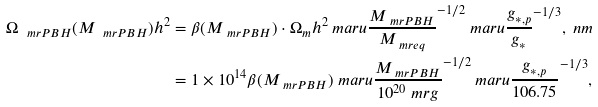Convert formula to latex. <formula><loc_0><loc_0><loc_500><loc_500>\Omega _ { \ m r { P B H } } ( M _ { \ m r { P B H } } ) h ^ { 2 } & = \beta ( M _ { \ m r { P B H } } ) \cdot \Omega _ { m } h ^ { 2 } \ m a r u { \frac { M _ { \ m r { P B H } } } { M _ { \ m r { e q } } } } ^ { - 1 / 2 } \ m a r u { \frac { g _ { \ast , p } } { g _ { \ast } } } ^ { - 1 / 3 } , \ n m \\ & = 1 \times 1 0 ^ { 1 4 } \beta ( M _ { \ m r { P B H } } ) \ m a r u { \frac { M _ { \ m r { P B H } } } { 1 0 ^ { 2 0 } \ m r { g } } } ^ { - 1 / 2 } \ m a r u { \frac { g _ { \ast , p } } { 1 0 6 . 7 5 } } ^ { - 1 / 3 } ,</formula> 